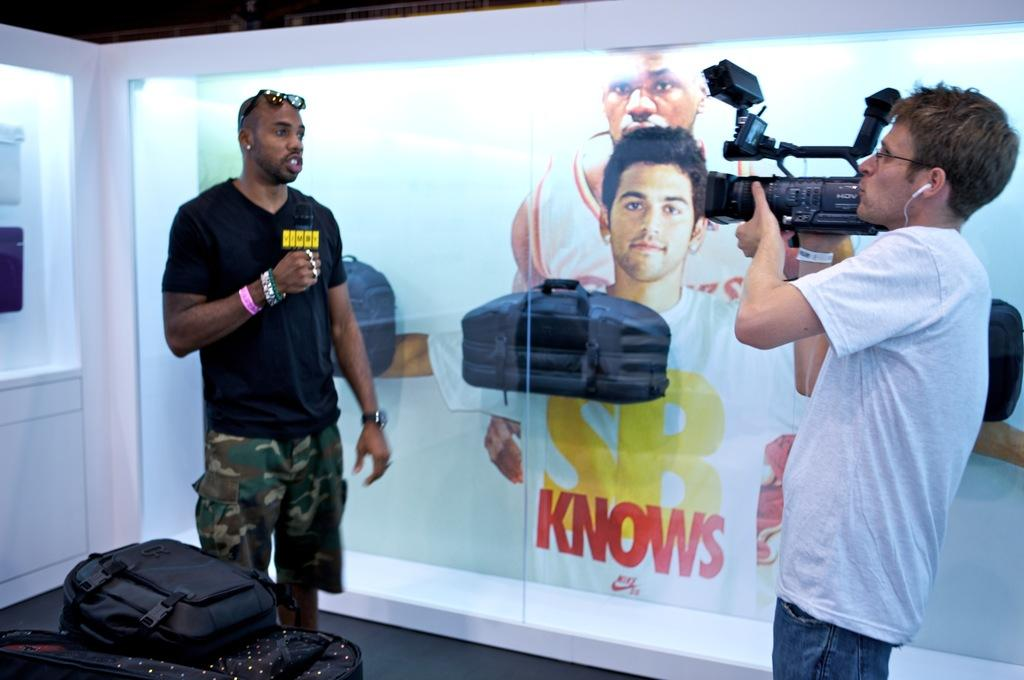What is the man in the image holding? The man is holding a camera. What is the other person in the image holding? The other person is holding a microphone. What objects can be seen in the image besides the camera and microphone? There are bags and lights visible in the image. What can be seen on the poster in the image? There is a poster of two persons in the image. Reasoning: Let's think step by step by step in order to produce the conversation. We start by identifying the main subjects in the image, which are the man holding a camera and the other person holding a microphone. Then, we expand the conversation to include other objects that are also visible, such as bags, lights, and the poster. Each question is designed to elicit a specific detail about the image that is known from the provided facts. Absurd Question/Answer: What type of bird can be seen flying in the image? There are no birds visible in the image. What type of property is being discussed in the image? The image does not depict any property or discussion about property. What type of pest can be seen crawling on the poster in the image? There are no pests visible on the poster or anywhere else in the image. 